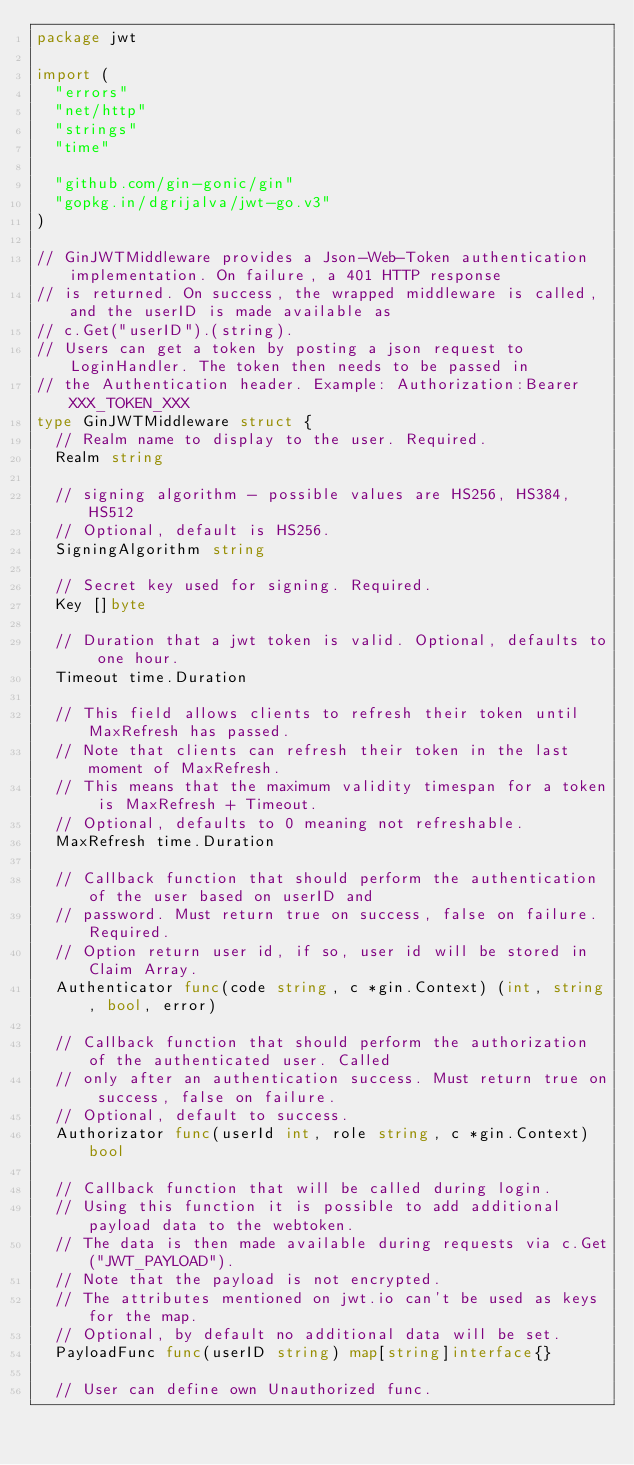<code> <loc_0><loc_0><loc_500><loc_500><_Go_>package jwt

import (
	"errors"
	"net/http"
	"strings"
	"time"

	"github.com/gin-gonic/gin"
	"gopkg.in/dgrijalva/jwt-go.v3"
)

// GinJWTMiddleware provides a Json-Web-Token authentication implementation. On failure, a 401 HTTP response
// is returned. On success, the wrapped middleware is called, and the userID is made available as
// c.Get("userID").(string).
// Users can get a token by posting a json request to LoginHandler. The token then needs to be passed in
// the Authentication header. Example: Authorization:Bearer XXX_TOKEN_XXX
type GinJWTMiddleware struct {
	// Realm name to display to the user. Required.
	Realm string

	// signing algorithm - possible values are HS256, HS384, HS512
	// Optional, default is HS256.
	SigningAlgorithm string

	// Secret key used for signing. Required.
	Key []byte

	// Duration that a jwt token is valid. Optional, defaults to one hour.
	Timeout time.Duration

	// This field allows clients to refresh their token until MaxRefresh has passed.
	// Note that clients can refresh their token in the last moment of MaxRefresh.
	// This means that the maximum validity timespan for a token is MaxRefresh + Timeout.
	// Optional, defaults to 0 meaning not refreshable.
	MaxRefresh time.Duration

	// Callback function that should perform the authentication of the user based on userID and
	// password. Must return true on success, false on failure. Required.
	// Option return user id, if so, user id will be stored in Claim Array.
	Authenticator func(code string, c *gin.Context) (int, string, bool, error)

	// Callback function that should perform the authorization of the authenticated user. Called
	// only after an authentication success. Must return true on success, false on failure.
	// Optional, default to success.
	Authorizator func(userId int, role string, c *gin.Context) bool

	// Callback function that will be called during login.
	// Using this function it is possible to add additional payload data to the webtoken.
	// The data is then made available during requests via c.Get("JWT_PAYLOAD").
	// Note that the payload is not encrypted.
	// The attributes mentioned on jwt.io can't be used as keys for the map.
	// Optional, by default no additional data will be set.
	PayloadFunc func(userID string) map[string]interface{}

	// User can define own Unauthorized func.</code> 